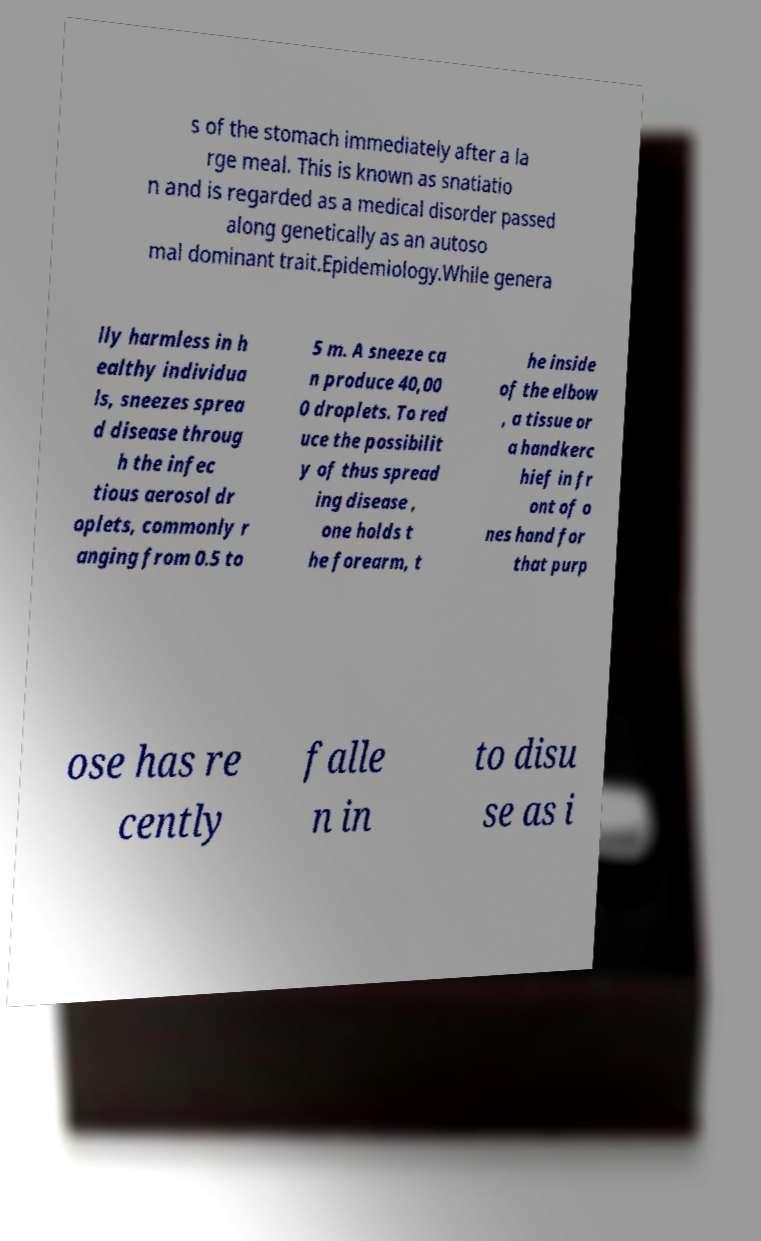Can you accurately transcribe the text from the provided image for me? s of the stomach immediately after a la rge meal. This is known as snatiatio n and is regarded as a medical disorder passed along genetically as an autoso mal dominant trait.Epidemiology.While genera lly harmless in h ealthy individua ls, sneezes sprea d disease throug h the infec tious aerosol dr oplets, commonly r anging from 0.5 to 5 m. A sneeze ca n produce 40,00 0 droplets. To red uce the possibilit y of thus spread ing disease , one holds t he forearm, t he inside of the elbow , a tissue or a handkerc hief in fr ont of o nes hand for that purp ose has re cently falle n in to disu se as i 